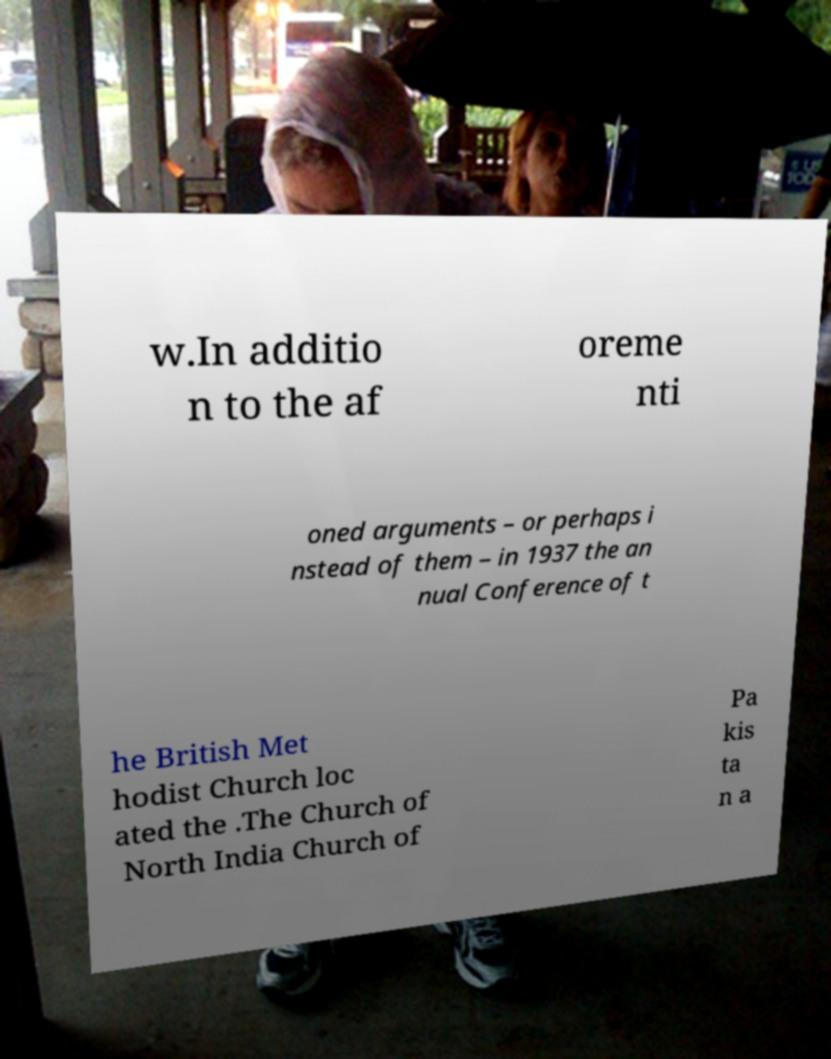Please identify and transcribe the text found in this image. w.In additio n to the af oreme nti oned arguments – or perhaps i nstead of them – in 1937 the an nual Conference of t he British Met hodist Church loc ated the .The Church of North India Church of Pa kis ta n a 